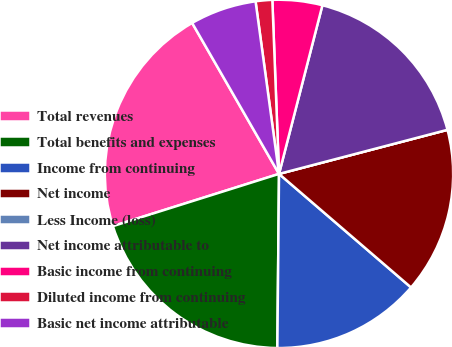Convert chart to OTSL. <chart><loc_0><loc_0><loc_500><loc_500><pie_chart><fcel>Total revenues<fcel>Total benefits and expenses<fcel>Income from continuing<fcel>Net income<fcel>Less Income (loss)<fcel>Net income attributable to<fcel>Basic income from continuing<fcel>Diluted income from continuing<fcel>Basic net income attributable<nl><fcel>21.54%<fcel>20.0%<fcel>13.85%<fcel>15.38%<fcel>0.0%<fcel>16.92%<fcel>4.62%<fcel>1.54%<fcel>6.16%<nl></chart> 